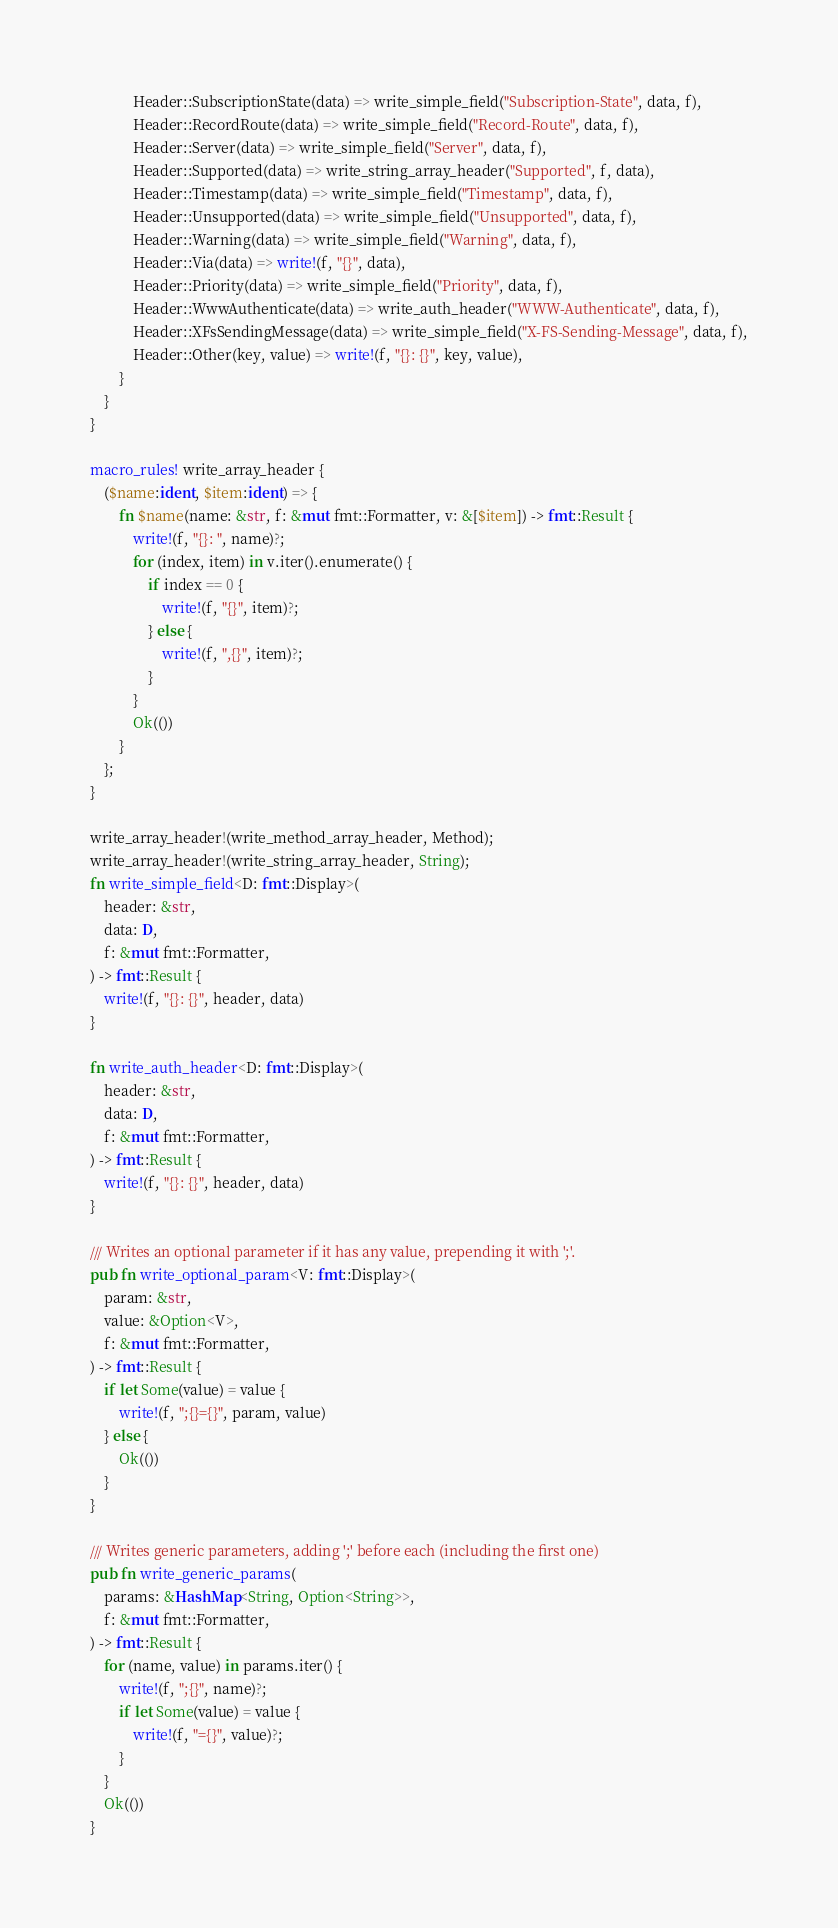<code> <loc_0><loc_0><loc_500><loc_500><_Rust_>            Header::SubscriptionState(data) => write_simple_field("Subscription-State", data, f),
            Header::RecordRoute(data) => write_simple_field("Record-Route", data, f),
            Header::Server(data) => write_simple_field("Server", data, f),
            Header::Supported(data) => write_string_array_header("Supported", f, data),
            Header::Timestamp(data) => write_simple_field("Timestamp", data, f),
            Header::Unsupported(data) => write_simple_field("Unsupported", data, f),
            Header::Warning(data) => write_simple_field("Warning", data, f),
            Header::Via(data) => write!(f, "{}", data),
            Header::Priority(data) => write_simple_field("Priority", data, f),
            Header::WwwAuthenticate(data) => write_auth_header("WWW-Authenticate", data, f),
            Header::XFsSendingMessage(data) => write_simple_field("X-FS-Sending-Message", data, f),
            Header::Other(key, value) => write!(f, "{}: {}", key, value),
        }
    }
}

macro_rules! write_array_header {
    ($name:ident, $item:ident) => {
        fn $name(name: &str, f: &mut fmt::Formatter, v: &[$item]) -> fmt::Result {
            write!(f, "{}: ", name)?;
            for (index, item) in v.iter().enumerate() {
                if index == 0 {
                    write!(f, "{}", item)?;
                } else {
                    write!(f, ",{}", item)?;
                }
            }
            Ok(())
        }
    };
}

write_array_header!(write_method_array_header, Method);
write_array_header!(write_string_array_header, String);
fn write_simple_field<D: fmt::Display>(
    header: &str,
    data: D,
    f: &mut fmt::Formatter,
) -> fmt::Result {
    write!(f, "{}: {}", header, data)
}

fn write_auth_header<D: fmt::Display>(
    header: &str,
    data: D,
    f: &mut fmt::Formatter,
) -> fmt::Result {
    write!(f, "{}: {}", header, data)
}

/// Writes an optional parameter if it has any value, prepending it with ';'.
pub fn write_optional_param<V: fmt::Display>(
    param: &str,
    value: &Option<V>,
    f: &mut fmt::Formatter,
) -> fmt::Result {
    if let Some(value) = value {
        write!(f, ";{}={}", param, value)
    } else {
        Ok(())
    }
}

/// Writes generic parameters, adding ';' before each (including the first one)
pub fn write_generic_params(
    params: &HashMap<String, Option<String>>,
    f: &mut fmt::Formatter,
) -> fmt::Result {
    for (name, value) in params.iter() {
        write!(f, ";{}", name)?;
        if let Some(value) = value {
            write!(f, "={}", value)?;
        }
    }
    Ok(())
}
</code> 